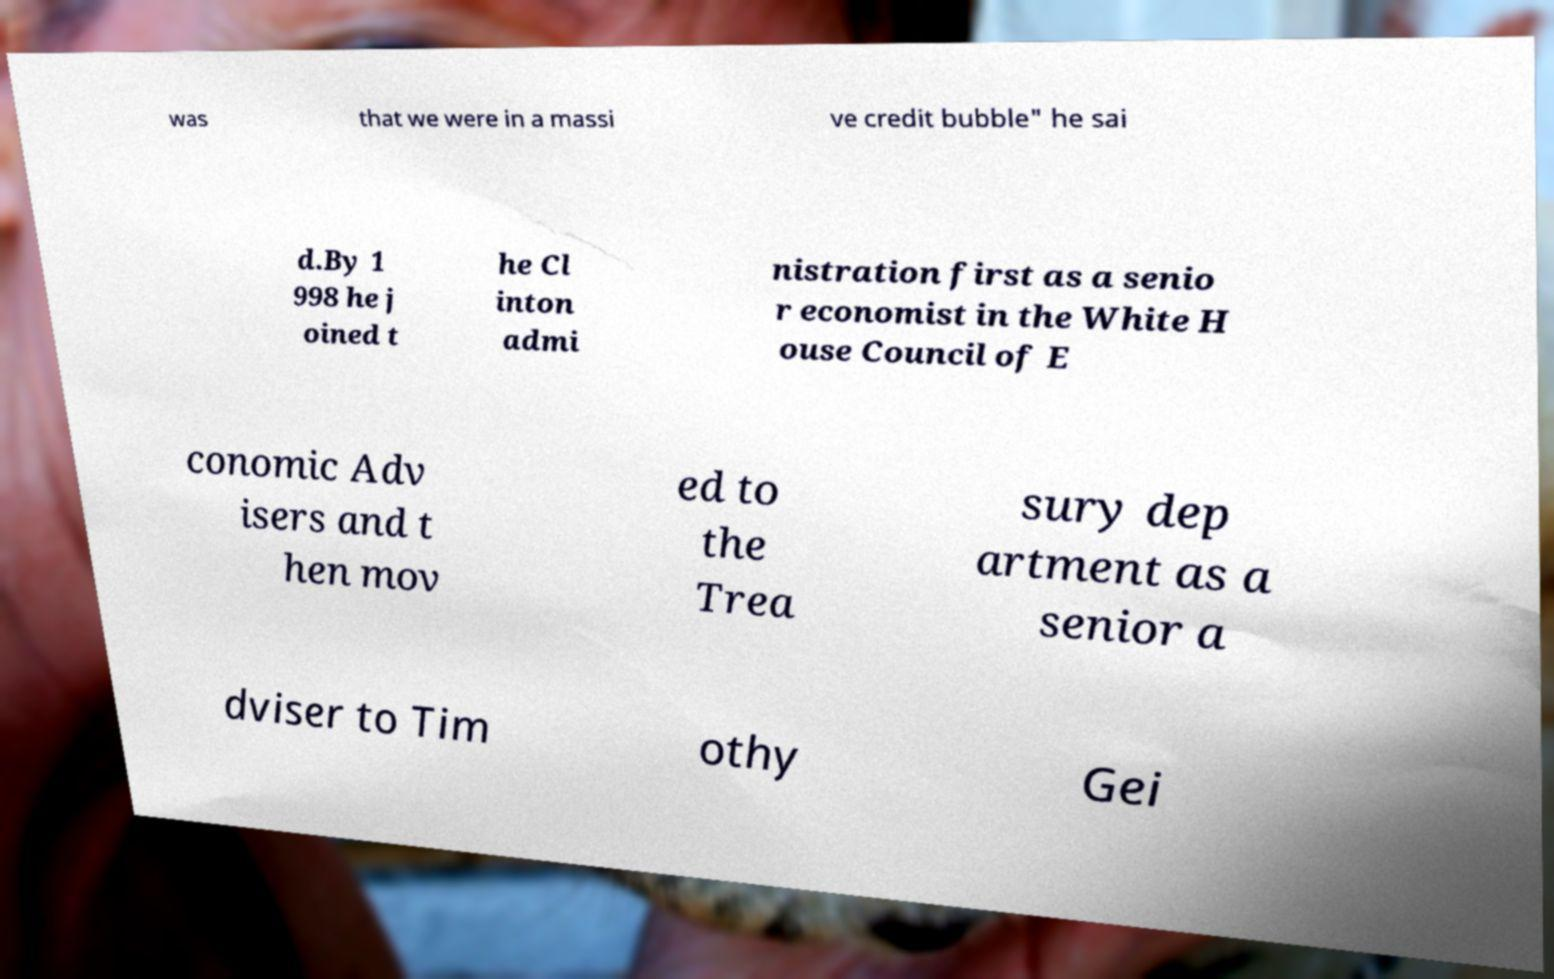Please identify and transcribe the text found in this image. was that we were in a massi ve credit bubble" he sai d.By 1 998 he j oined t he Cl inton admi nistration first as a senio r economist in the White H ouse Council of E conomic Adv isers and t hen mov ed to the Trea sury dep artment as a senior a dviser to Tim othy Gei 